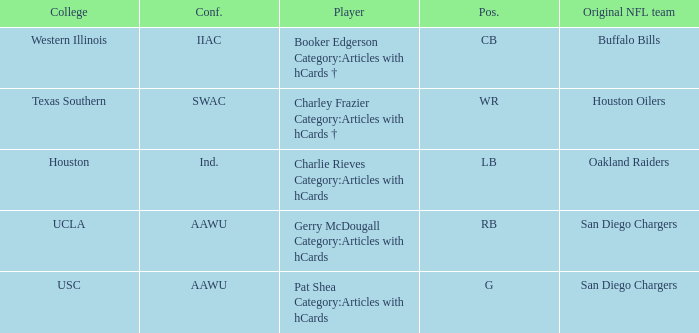What player's original team are the Buffalo Bills? Booker Edgerson Category:Articles with hCards †. 